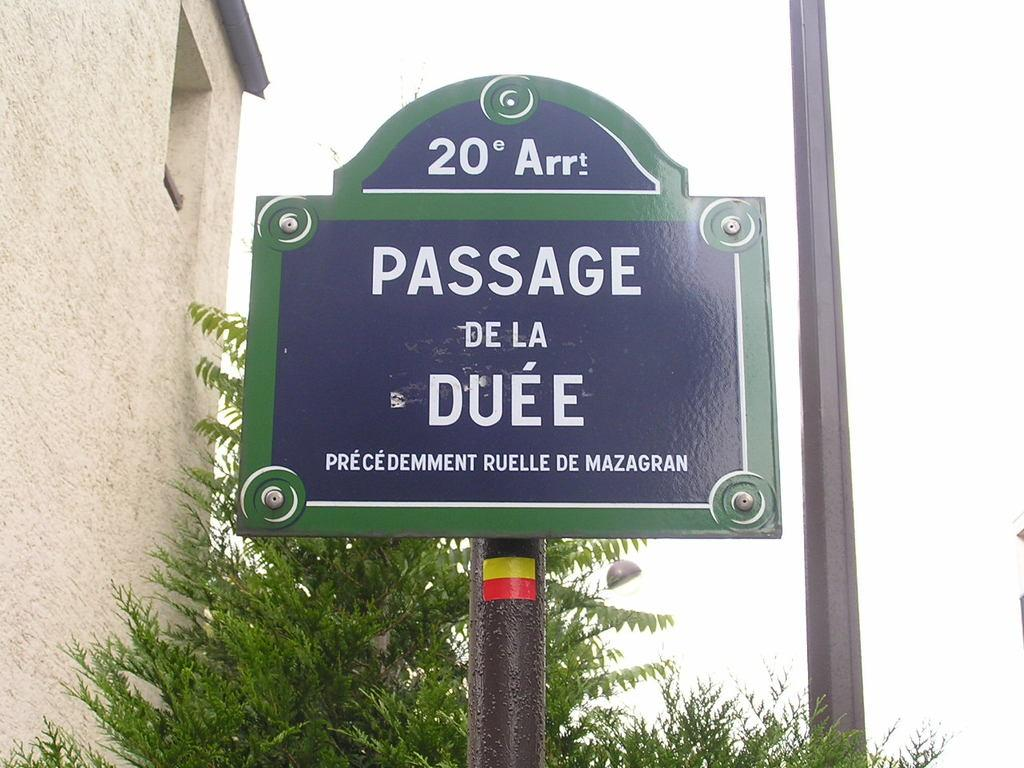What is the main object in the foreground of the image? There is a sign board with a pole in the image. What can be seen in the background of the image? There is a tree, a wall, and a pillar in the background of the image. What type of record is being played on the sign board in the image? There is no record or sound system present in the image; it only features a sign board with a pole. What game is being played on the pillar in the image? There is no game or activity depicted on the pillar in the image. 